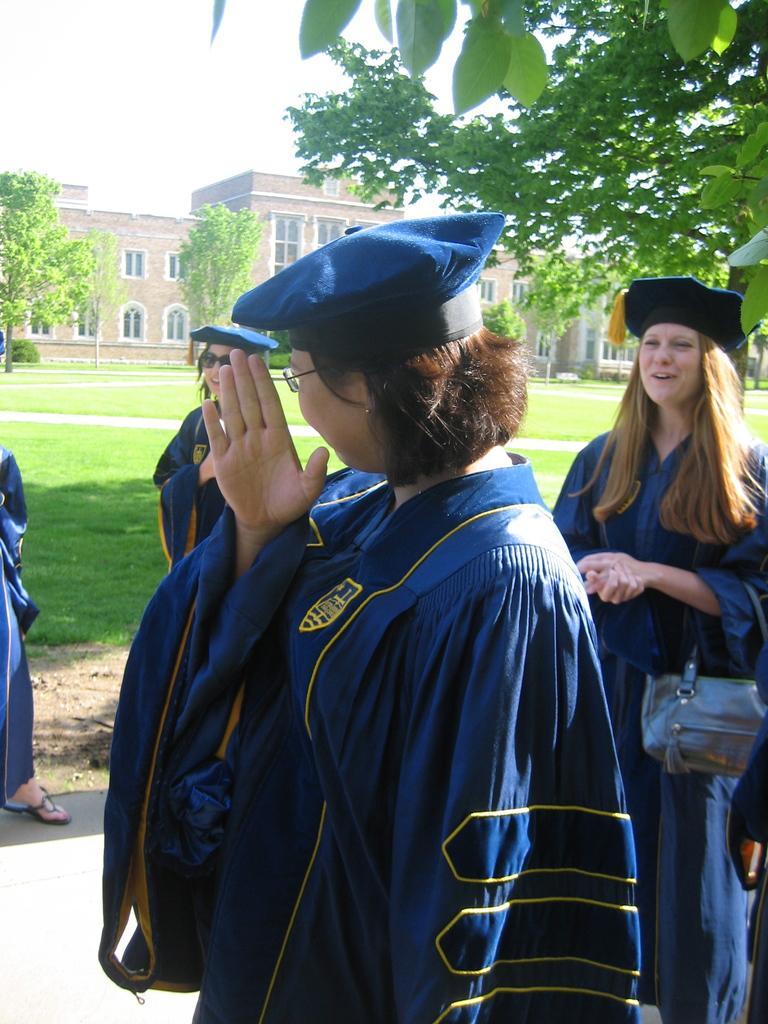Describe this image in one or two sentences. In this image, we can see persons wearing clothes and caps. There is a building and some trees in the middle of the image. There is a sky at the top of the image. 